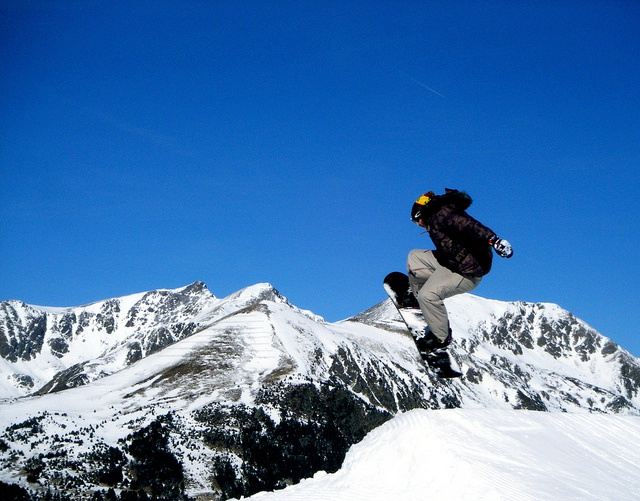Describe the objects in this image and their specific colors. I can see people in navy, black, darkgray, and gray tones and snowboard in navy, black, white, darkgray, and gray tones in this image. 